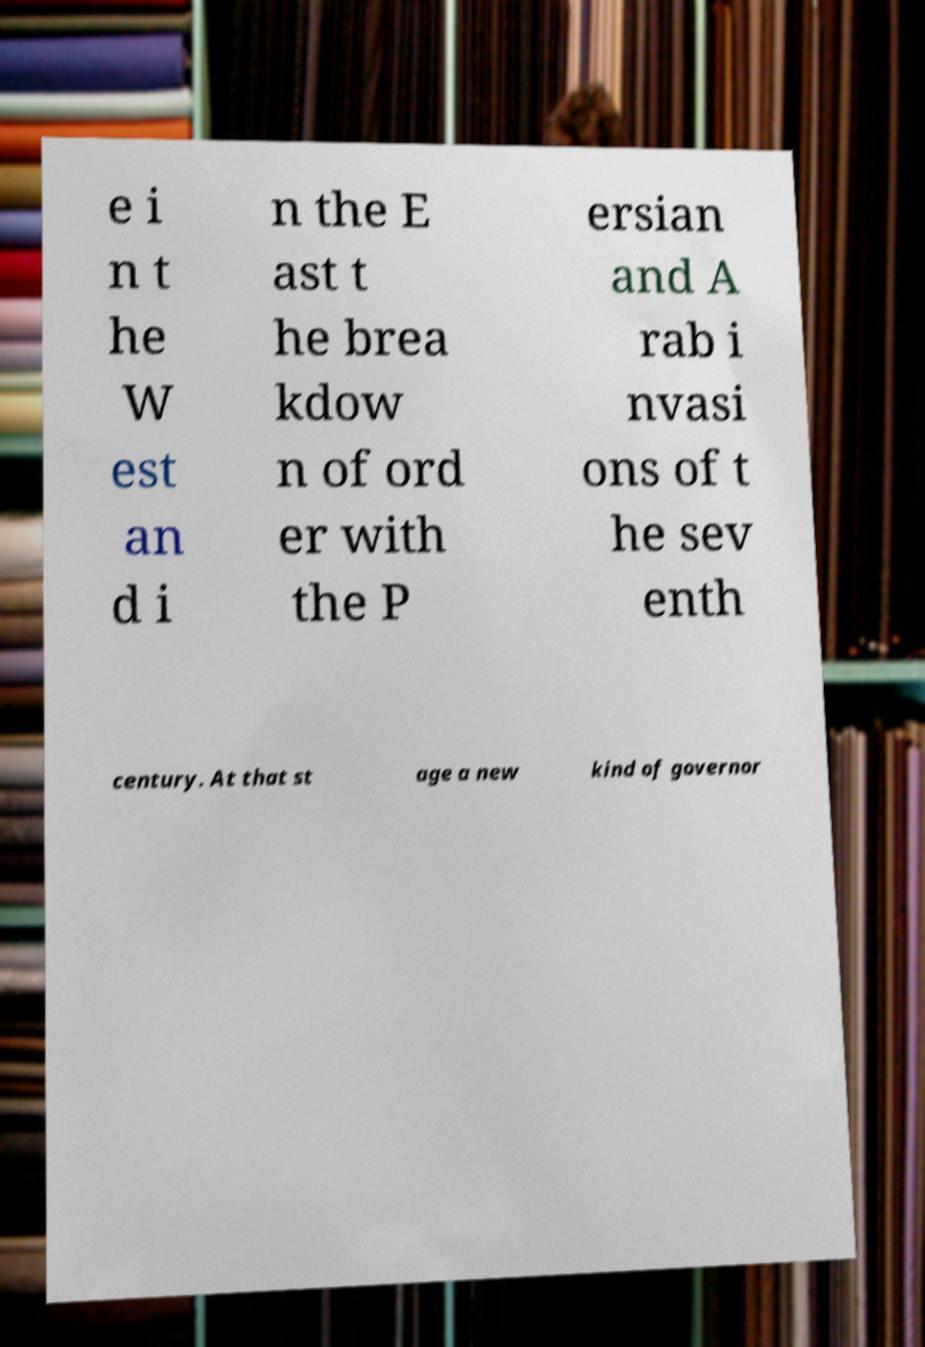Could you extract and type out the text from this image? e i n t he W est an d i n the E ast t he brea kdow n of ord er with the P ersian and A rab i nvasi ons of t he sev enth century. At that st age a new kind of governor 